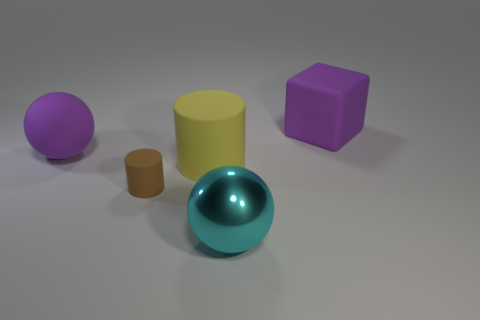What shape is the matte thing that is the same color as the matte cube?
Keep it short and to the point. Sphere. Does the rubber ball have the same color as the large rubber cube?
Give a very brief answer. Yes. Is the number of large cylinders that are on the left side of the rubber ball greater than the number of brown rubber things?
Offer a terse response. No. Does the cyan object have the same size as the yellow cylinder?
Give a very brief answer. Yes. What material is the large purple object that is the same shape as the big cyan object?
Give a very brief answer. Rubber. Are there any other things that have the same material as the yellow cylinder?
Provide a short and direct response. Yes. How many yellow objects are metal spheres or large rubber things?
Give a very brief answer. 1. There is a small object that is to the left of the large cyan object; what is it made of?
Make the answer very short. Rubber. Are there more small yellow cylinders than cyan balls?
Your answer should be very brief. No. There is a large object right of the big metallic sphere; is its shape the same as the cyan metal object?
Give a very brief answer. No. 